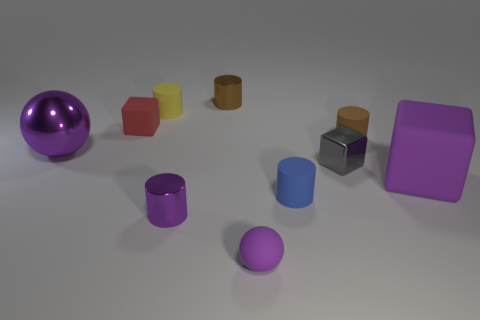Subtract all red cylinders. Subtract all green cubes. How many cylinders are left? 5 Subtract all blocks. How many objects are left? 7 Add 4 small yellow objects. How many small yellow objects are left? 5 Add 8 tiny purple rubber spheres. How many tiny purple rubber spheres exist? 9 Subtract 0 brown spheres. How many objects are left? 10 Subtract all big gray metallic cubes. Subtract all tiny rubber blocks. How many objects are left? 9 